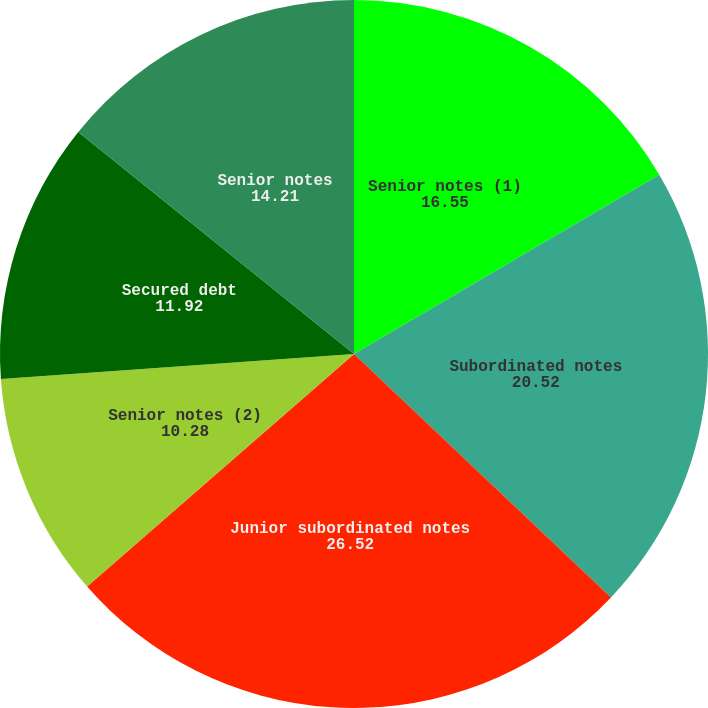Convert chart. <chart><loc_0><loc_0><loc_500><loc_500><pie_chart><fcel>Senior notes (1)<fcel>Subordinated notes<fcel>Junior subordinated notes<fcel>Senior notes (2)<fcel>Secured debt<fcel>Senior notes<nl><fcel>16.55%<fcel>20.52%<fcel>26.52%<fcel>10.28%<fcel>11.92%<fcel>14.21%<nl></chart> 